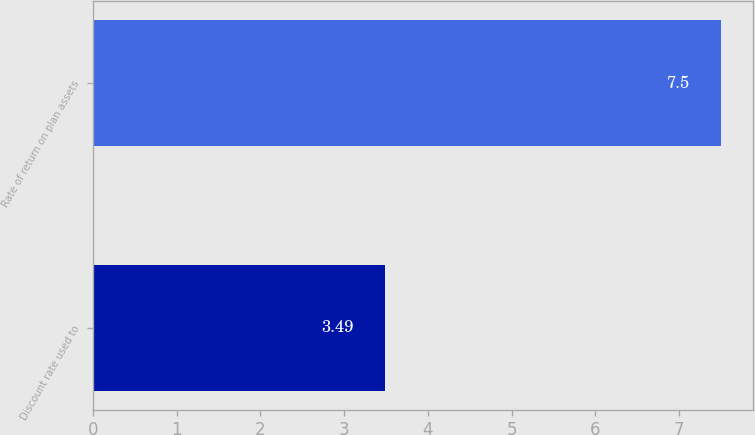<chart> <loc_0><loc_0><loc_500><loc_500><bar_chart><fcel>Discount rate used to<fcel>Rate of return on plan assets<nl><fcel>3.49<fcel>7.5<nl></chart> 